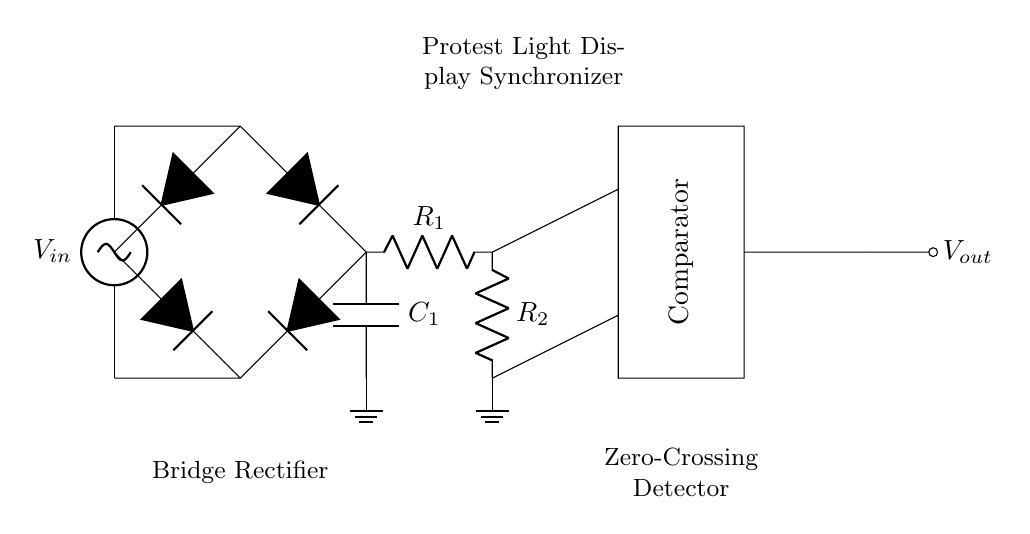What type of rectifier is used in this circuit? The diagram displays a bridge rectifier, which is identifiable by the arrangement of the four diodes in a bridge configuration, allowing for both halves of the AC waveform to be converted to DC.
Answer: Bridge rectifier What component smooths the output voltage? The smoothing capacitor is the component used to reduce fluctuations in the output voltage. It is located after the bridge rectifier and before the resistor divider.
Answer: Capacitor How many resistors are in the divider? The circuit has two resistors that are part of the resistor divider, situated after the smoothing capacitor and before the comparator.
Answer: Two What is the role of the comparator in this circuit? The comparator is used to detect the zero-crossing points of the AC signal, which it does by comparing the voltage levels at its inputs. This information helps synchronize the light displays with the AC waveform.
Answer: Zero-crossing detection What is the purpose of the bridge rectifier in this circuit? The bridge rectifier converts the alternating current (AC) input voltage into a direct current (DC) voltage output, which is necessary for powering the LED light displays effectively.
Answer: Convert AC to DC What does the output node of this circuit represent? The output node, labeled as V out, represents the smoothed and rectified DC voltage that has been processed through the circuit and is ready for use in the protest light display.
Answer: Output voltage 